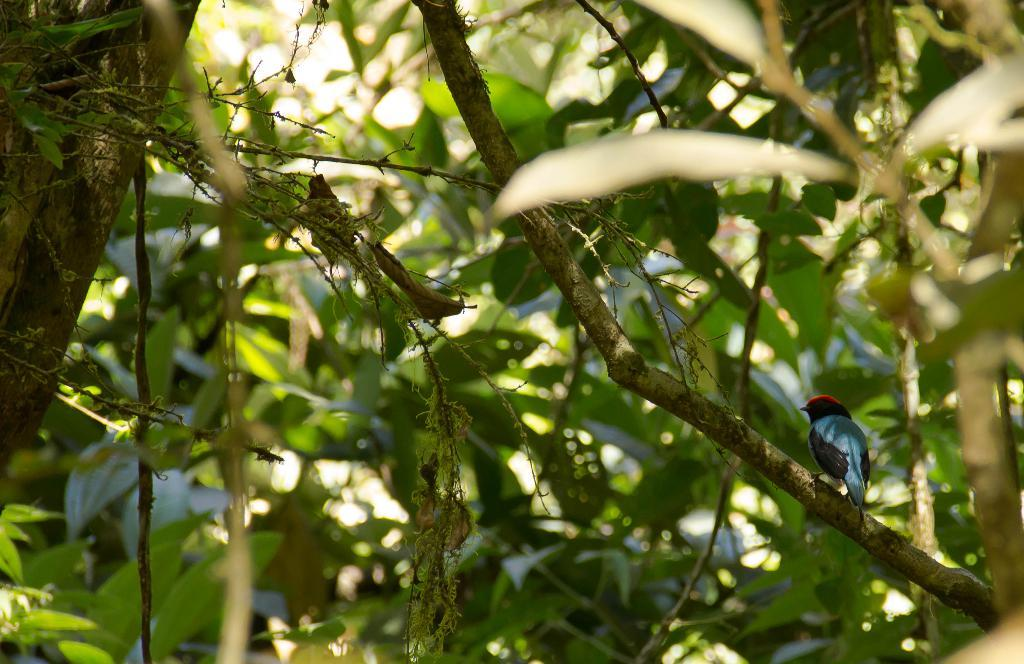What type of vegetation can be seen in the image? There are trees in the image. Are there any animals visible in the image? Yes, there is a bird in the image. Where is the bird located in the image? The bird is on a branch in the image. What type of mask is the stranger wearing in the image? There is no stranger or mask present in the image; it only features trees and a bird on a branch. 